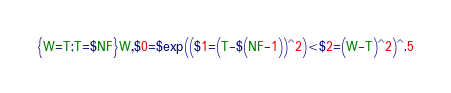<code> <loc_0><loc_0><loc_500><loc_500><_Awk_>{W=T;T=$NF}W,$0=$exp(($1=(T-$(NF-1))^2)<$2=(W-T)^2)^.5</code> 